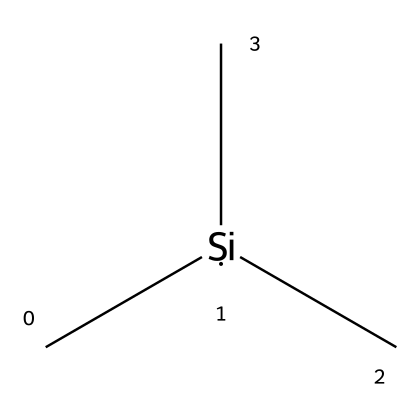What is the molecular formula of trimethylsilane? By analyzing the SMILES representation, C[Si](C)C indicates that there is one silicon (Si) atom and three carbon (C) atoms associated with it. Therefore, the molecular formula can be deduced as C3H12Si, taking into account that each carbon typically forms four bonds.
Answer: C3H12Si How many silicon atoms are present in trimethylsilane? The SMILES representation shows a single [Si] within the structure, indicating that there is only one silicon atom in trimethylsilane.
Answer: 1 What type of bonding is primarily found in trimethylsilane? The structure indicates that carbon atoms (C) are bonded to silicon (Si) via single covalent bonds. Given the molecular composition, the bonding is predominantly covalent due to the non-metal character of both silicon and carbon.
Answer: covalent What is the hybridization of the silicon atom in trimethylsilane? The silicon atom in trimethylsilane is bonded to three carbon atoms and has one empty p-orbital, making it sp3 hybridized. This classification arises from the typical tetrahedral geometry expected in such configurations.
Answer: sp3 Is trimethylsilane a solid, liquid, or gas at room temperature? Trimethylsilane is typically a gas at room temperature, as most silanes with small molecular sizes are gaseous at standard conditions. The volatility of the compound can be inferred from its chemical structure.
Answer: gas What industrial application is primarily associated with trimethylsilane? Trimethylsilane is commonly used as a precursor in the production of silicon-based materials in semiconductor manufacturing, particularly during the deposition processes.
Answer: semiconductor manufacturing 